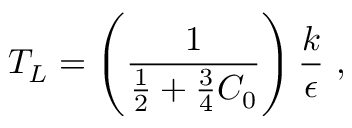<formula> <loc_0><loc_0><loc_500><loc_500>T _ { L } = \left ( \frac { 1 } { \frac { 1 } { 2 } + \frac { 3 } { 4 } C _ { 0 } } \right ) \frac { k } { \epsilon } ,</formula> 